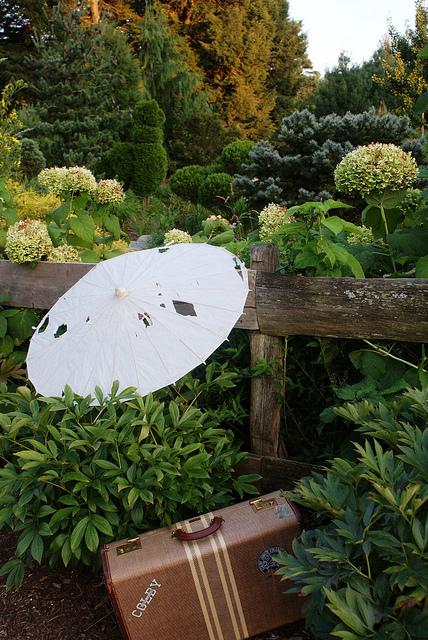What color is the umbrella?
Quick response, please. White. What color are the plants?
Quick response, please. Green. Is this a good place to put a suitcase?
Short answer required. No. 